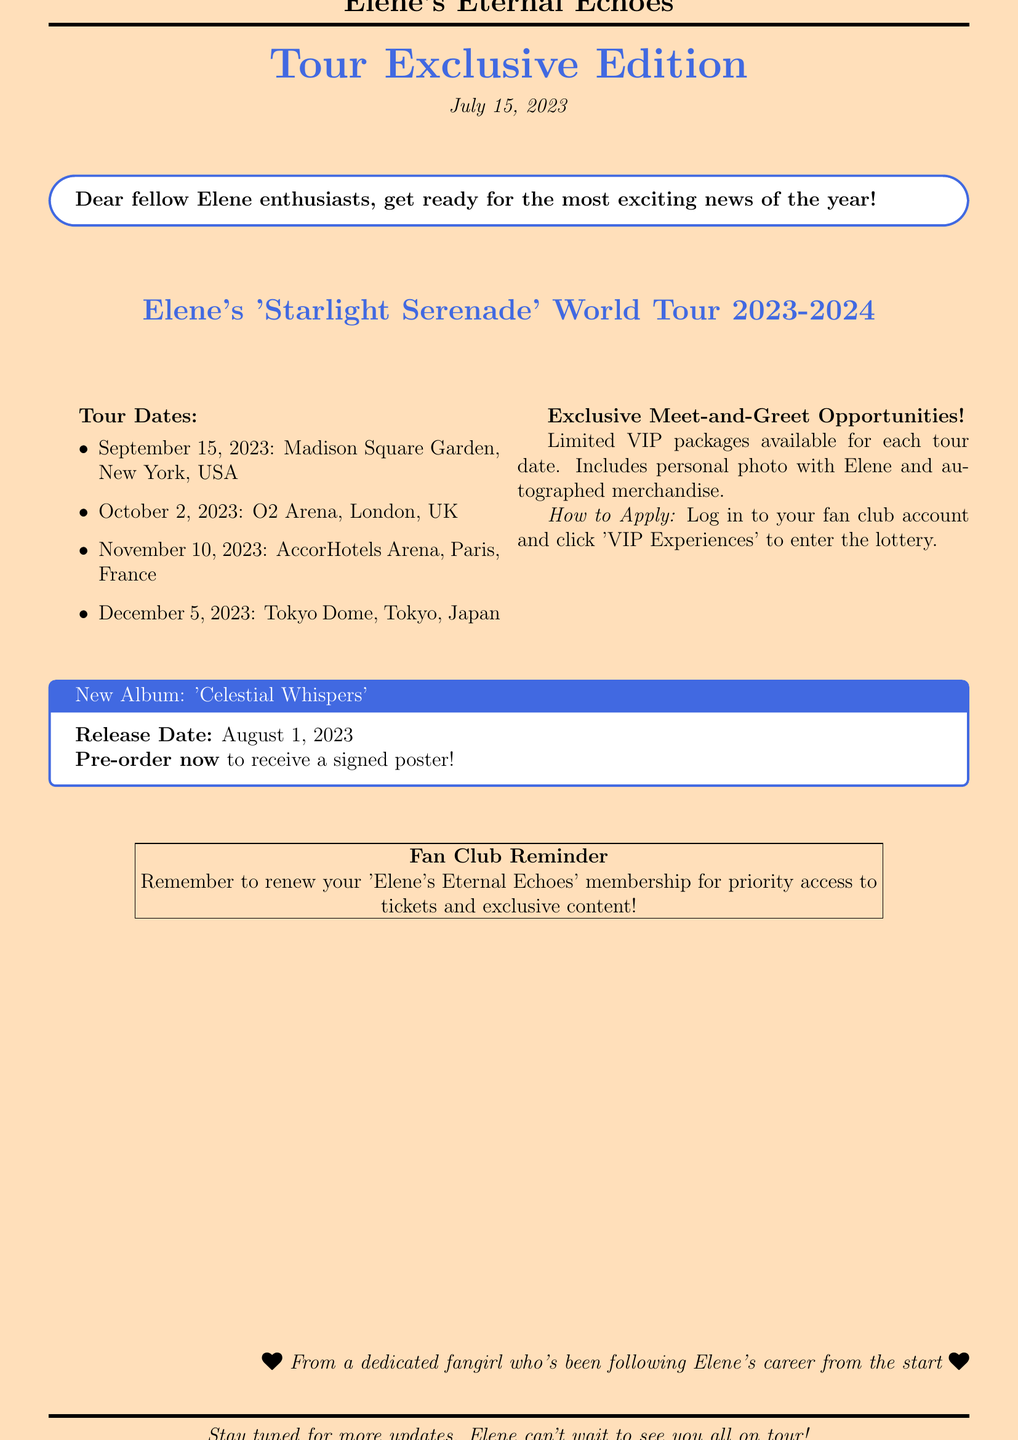What is the title of Elene's upcoming tour? The title of the tour is mentioned prominently at the beginning of the document.
Answer: 'Starlight Serenade' World Tour 2023-2024 When is the tour date for Madison Square Garden? This specific tour date is listed under the tour dates section in the document.
Answer: September 15, 2023 Where will Elene perform on October 2, 2023? The location for this specific date is provided in the tour dates list.
Answer: O2 Arena, London, UK What is included in the VIP packages? The document specifies what is included in the exclusive meet-and-greet opportunities section.
Answer: Personal photo with Elene and autographed merchandise How can fans apply for the meet-and-greet? The document details the application process in the exclusive meet-and-greet opportunities section.
Answer: Log in to your fan club account and click 'VIP Experiences' What is the release date of Elene's new album? The release date is clearly stated in the new album section of the document.
Answer: August 1, 2023 What must fans remember to do for priority access? This reminder is stated in the fan club section of the document.
Answer: Renew your 'Elene's Eternal Echoes' membership Who is the document signed off by? The closing statement identifies the sender of the document.
Answer: A dedicated fangirl who's been following Elene's career from the start 